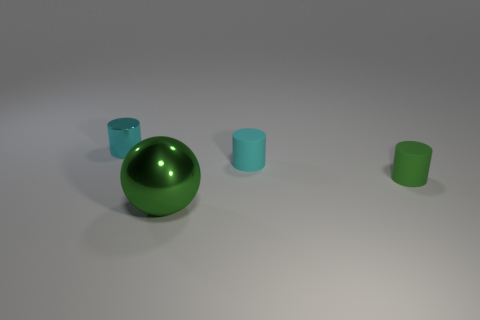How many other objects are the same material as the large green object?
Provide a succinct answer. 1. There is a cyan thing that is the same size as the cyan metal cylinder; what is its shape?
Provide a short and direct response. Cylinder. There is a small object left of the green shiny sphere; what color is it?
Keep it short and to the point. Cyan. How many things are cylinders that are left of the big green metallic ball or shiny things behind the green cylinder?
Offer a very short reply. 1. Do the green shiny thing and the cyan rubber object have the same size?
Keep it short and to the point. No. What number of cylinders are either shiny objects or small green objects?
Your answer should be compact. 2. What number of objects are in front of the cyan metallic cylinder and behind the green metallic thing?
Keep it short and to the point. 2. There is a green cylinder; is its size the same as the shiny object that is behind the tiny green rubber cylinder?
Your answer should be compact. Yes. There is a small cyan object left of the object in front of the small green cylinder; are there any shiny things left of it?
Ensure brevity in your answer.  No. There is a object that is in front of the green thing that is on the right side of the sphere; what is it made of?
Provide a short and direct response. Metal. 